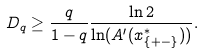Convert formula to latex. <formula><loc_0><loc_0><loc_500><loc_500>D _ { q } \geq \frac { q } { 1 - q } \frac { \ln 2 } { \ln ( A ^ { \prime } ( x ^ { * } _ { \{ + - \} } ) ) } .</formula> 